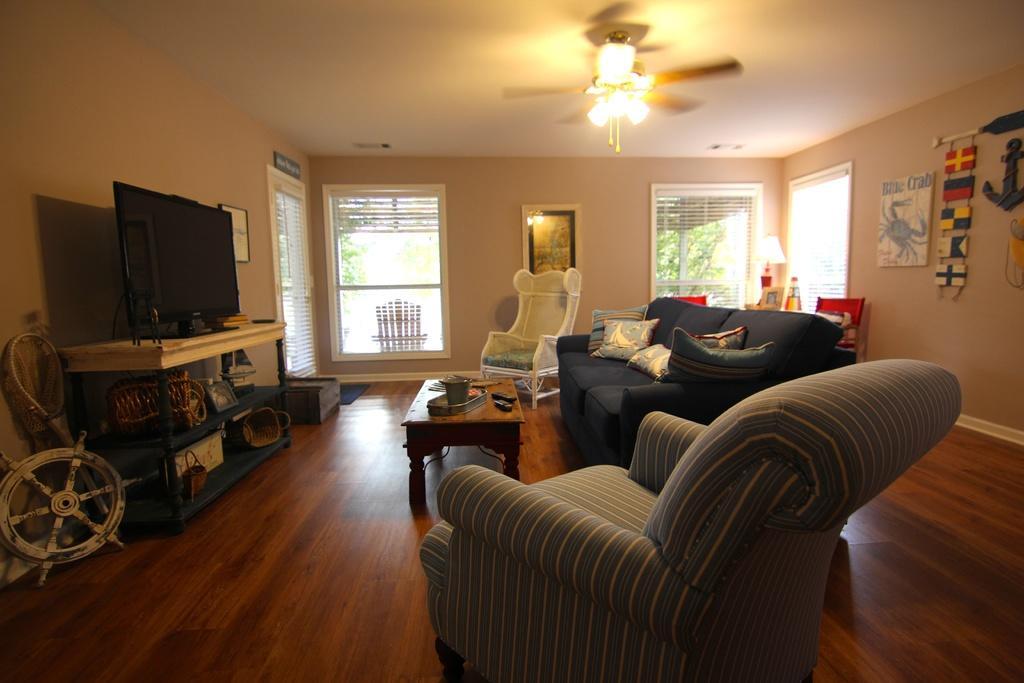Could you give a brief overview of what you see in this image? In this picture we can see a room with sofa and pillows on it, chair and here on table we can see remote and television and the background we can see wall with frames, windows, lamp. 